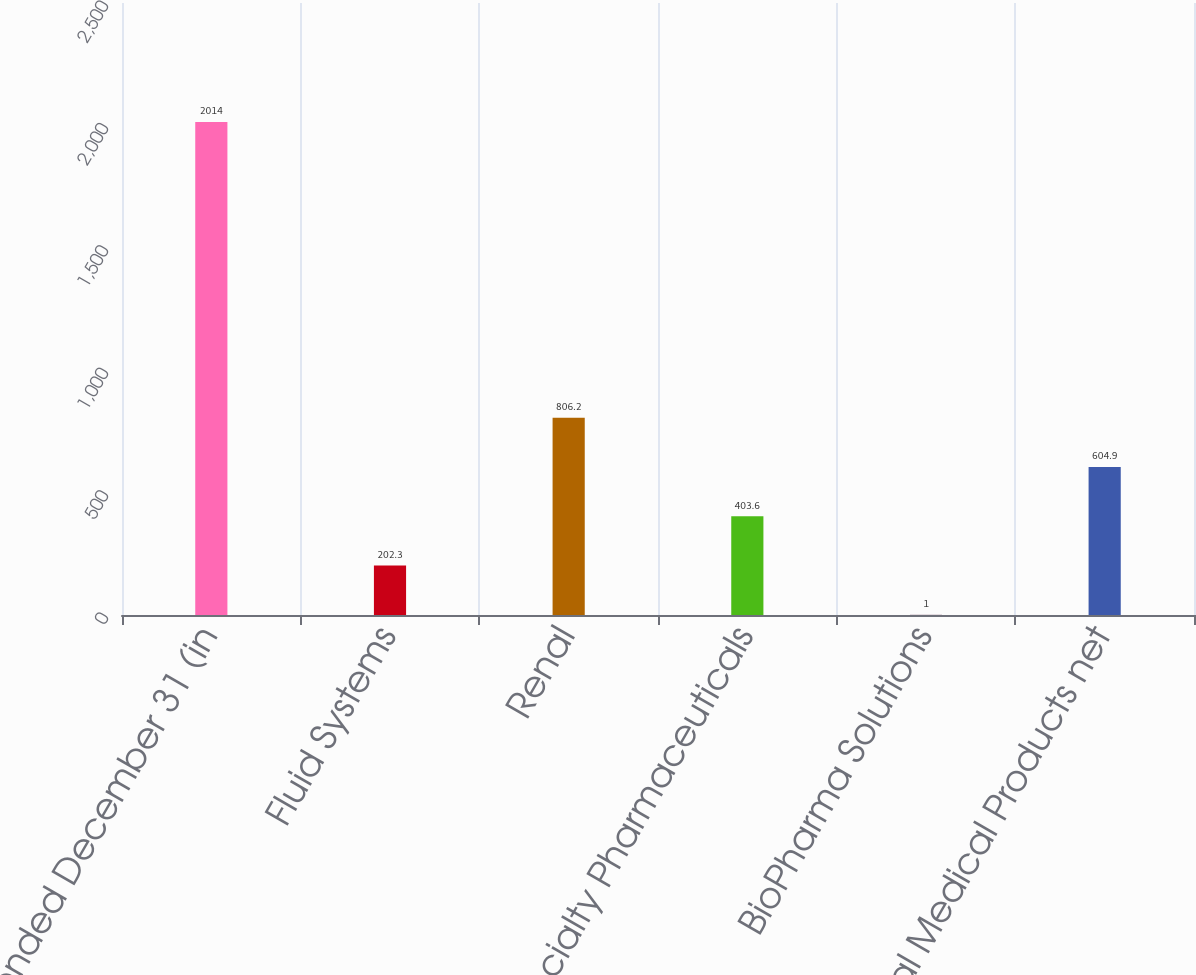Convert chart to OTSL. <chart><loc_0><loc_0><loc_500><loc_500><bar_chart><fcel>years ended December 31 (in<fcel>Fluid Systems<fcel>Renal<fcel>Specialty Pharmaceuticals<fcel>BioPharma Solutions<fcel>Total Medical Products net<nl><fcel>2014<fcel>202.3<fcel>806.2<fcel>403.6<fcel>1<fcel>604.9<nl></chart> 